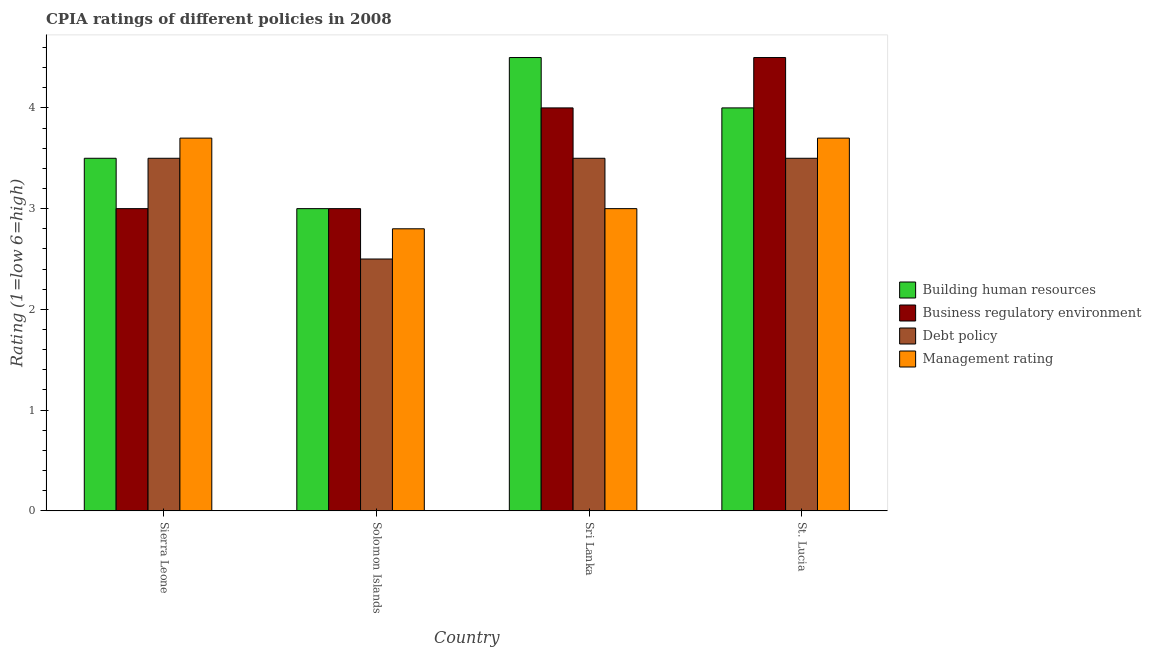How many different coloured bars are there?
Your answer should be very brief. 4. Are the number of bars per tick equal to the number of legend labels?
Ensure brevity in your answer.  Yes. How many bars are there on the 2nd tick from the left?
Provide a short and direct response. 4. What is the label of the 1st group of bars from the left?
Provide a succinct answer. Sierra Leone. In how many cases, is the number of bars for a given country not equal to the number of legend labels?
Provide a short and direct response. 0. What is the cpia rating of business regulatory environment in Sierra Leone?
Provide a short and direct response. 3. Across all countries, what is the minimum cpia rating of debt policy?
Offer a terse response. 2.5. In which country was the cpia rating of building human resources maximum?
Your response must be concise. Sri Lanka. In which country was the cpia rating of building human resources minimum?
Ensure brevity in your answer.  Solomon Islands. What is the difference between the cpia rating of building human resources in Solomon Islands and the cpia rating of management in St. Lucia?
Provide a succinct answer. -0.7. What is the average cpia rating of business regulatory environment per country?
Your response must be concise. 3.62. What is the difference between the cpia rating of building human resources and cpia rating of debt policy in St. Lucia?
Offer a very short reply. 0.5. In how many countries, is the cpia rating of building human resources greater than 2.8 ?
Your response must be concise. 4. Is the cpia rating of business regulatory environment in Solomon Islands less than that in St. Lucia?
Ensure brevity in your answer.  Yes. Is the difference between the cpia rating of business regulatory environment in Sri Lanka and St. Lucia greater than the difference between the cpia rating of building human resources in Sri Lanka and St. Lucia?
Your response must be concise. No. What is the difference between the highest and the lowest cpia rating of building human resources?
Offer a very short reply. 1.5. In how many countries, is the cpia rating of debt policy greater than the average cpia rating of debt policy taken over all countries?
Keep it short and to the point. 3. Is the sum of the cpia rating of business regulatory environment in Sierra Leone and St. Lucia greater than the maximum cpia rating of building human resources across all countries?
Make the answer very short. Yes. Is it the case that in every country, the sum of the cpia rating of management and cpia rating of debt policy is greater than the sum of cpia rating of building human resources and cpia rating of business regulatory environment?
Your response must be concise. No. What does the 4th bar from the left in St. Lucia represents?
Your answer should be very brief. Management rating. What does the 2nd bar from the right in Sri Lanka represents?
Offer a terse response. Debt policy. How many bars are there?
Provide a short and direct response. 16. Are all the bars in the graph horizontal?
Ensure brevity in your answer.  No. How many countries are there in the graph?
Your answer should be compact. 4. What is the difference between two consecutive major ticks on the Y-axis?
Make the answer very short. 1. Does the graph contain grids?
Provide a short and direct response. No. Where does the legend appear in the graph?
Your answer should be very brief. Center right. How are the legend labels stacked?
Offer a terse response. Vertical. What is the title of the graph?
Provide a short and direct response. CPIA ratings of different policies in 2008. What is the label or title of the Y-axis?
Provide a short and direct response. Rating (1=low 6=high). What is the Rating (1=low 6=high) of Business regulatory environment in Sierra Leone?
Keep it short and to the point. 3. What is the Rating (1=low 6=high) in Debt policy in Sierra Leone?
Provide a succinct answer. 3.5. What is the Rating (1=low 6=high) of Business regulatory environment in Solomon Islands?
Your answer should be compact. 3. What is the Rating (1=low 6=high) of Building human resources in Sri Lanka?
Your answer should be very brief. 4.5. What is the Rating (1=low 6=high) in Business regulatory environment in Sri Lanka?
Your response must be concise. 4. Across all countries, what is the maximum Rating (1=low 6=high) of Business regulatory environment?
Provide a succinct answer. 4.5. Across all countries, what is the maximum Rating (1=low 6=high) in Management rating?
Your response must be concise. 3.7. Across all countries, what is the minimum Rating (1=low 6=high) of Building human resources?
Your answer should be very brief. 3. Across all countries, what is the minimum Rating (1=low 6=high) of Business regulatory environment?
Ensure brevity in your answer.  3. Across all countries, what is the minimum Rating (1=low 6=high) of Debt policy?
Give a very brief answer. 2.5. What is the total Rating (1=low 6=high) in Business regulatory environment in the graph?
Give a very brief answer. 14.5. What is the total Rating (1=low 6=high) in Debt policy in the graph?
Provide a short and direct response. 13. What is the difference between the Rating (1=low 6=high) in Management rating in Sierra Leone and that in Solomon Islands?
Ensure brevity in your answer.  0.9. What is the difference between the Rating (1=low 6=high) in Debt policy in Sierra Leone and that in Sri Lanka?
Your response must be concise. 0. What is the difference between the Rating (1=low 6=high) of Business regulatory environment in Sierra Leone and that in St. Lucia?
Ensure brevity in your answer.  -1.5. What is the difference between the Rating (1=low 6=high) in Building human resources in Solomon Islands and that in Sri Lanka?
Your response must be concise. -1.5. What is the difference between the Rating (1=low 6=high) in Debt policy in Solomon Islands and that in Sri Lanka?
Give a very brief answer. -1. What is the difference between the Rating (1=low 6=high) of Debt policy in Solomon Islands and that in St. Lucia?
Keep it short and to the point. -1. What is the difference between the Rating (1=low 6=high) in Building human resources in Sri Lanka and that in St. Lucia?
Give a very brief answer. 0.5. What is the difference between the Rating (1=low 6=high) of Business regulatory environment in Sri Lanka and that in St. Lucia?
Your answer should be very brief. -0.5. What is the difference between the Rating (1=low 6=high) in Debt policy in Sri Lanka and that in St. Lucia?
Provide a short and direct response. 0. What is the difference between the Rating (1=low 6=high) of Building human resources in Sierra Leone and the Rating (1=low 6=high) of Debt policy in Solomon Islands?
Give a very brief answer. 1. What is the difference between the Rating (1=low 6=high) in Business regulatory environment in Sierra Leone and the Rating (1=low 6=high) in Debt policy in Solomon Islands?
Ensure brevity in your answer.  0.5. What is the difference between the Rating (1=low 6=high) in Business regulatory environment in Sierra Leone and the Rating (1=low 6=high) in Management rating in Solomon Islands?
Ensure brevity in your answer.  0.2. What is the difference between the Rating (1=low 6=high) in Debt policy in Sierra Leone and the Rating (1=low 6=high) in Management rating in Solomon Islands?
Offer a very short reply. 0.7. What is the difference between the Rating (1=low 6=high) of Business regulatory environment in Sierra Leone and the Rating (1=low 6=high) of Debt policy in Sri Lanka?
Ensure brevity in your answer.  -0.5. What is the difference between the Rating (1=low 6=high) in Building human resources in Sierra Leone and the Rating (1=low 6=high) in Business regulatory environment in St. Lucia?
Provide a short and direct response. -1. What is the difference between the Rating (1=low 6=high) of Building human resources in Sierra Leone and the Rating (1=low 6=high) of Debt policy in St. Lucia?
Keep it short and to the point. 0. What is the difference between the Rating (1=low 6=high) in Building human resources in Sierra Leone and the Rating (1=low 6=high) in Management rating in St. Lucia?
Provide a short and direct response. -0.2. What is the difference between the Rating (1=low 6=high) of Business regulatory environment in Sierra Leone and the Rating (1=low 6=high) of Management rating in St. Lucia?
Your response must be concise. -0.7. What is the difference between the Rating (1=low 6=high) in Building human resources in Solomon Islands and the Rating (1=low 6=high) in Business regulatory environment in Sri Lanka?
Your response must be concise. -1. What is the difference between the Rating (1=low 6=high) of Business regulatory environment in Solomon Islands and the Rating (1=low 6=high) of Management rating in Sri Lanka?
Your answer should be compact. 0. What is the difference between the Rating (1=low 6=high) of Debt policy in Solomon Islands and the Rating (1=low 6=high) of Management rating in Sri Lanka?
Your answer should be very brief. -0.5. What is the difference between the Rating (1=low 6=high) of Business regulatory environment in Solomon Islands and the Rating (1=low 6=high) of Management rating in St. Lucia?
Offer a very short reply. -0.7. What is the difference between the Rating (1=low 6=high) in Debt policy in Solomon Islands and the Rating (1=low 6=high) in Management rating in St. Lucia?
Your answer should be very brief. -1.2. What is the difference between the Rating (1=low 6=high) of Building human resources in Sri Lanka and the Rating (1=low 6=high) of Business regulatory environment in St. Lucia?
Offer a very short reply. 0. What is the difference between the Rating (1=low 6=high) in Building human resources in Sri Lanka and the Rating (1=low 6=high) in Management rating in St. Lucia?
Provide a short and direct response. 0.8. What is the difference between the Rating (1=low 6=high) of Business regulatory environment in Sri Lanka and the Rating (1=low 6=high) of Debt policy in St. Lucia?
Provide a succinct answer. 0.5. What is the difference between the Rating (1=low 6=high) in Debt policy in Sri Lanka and the Rating (1=low 6=high) in Management rating in St. Lucia?
Ensure brevity in your answer.  -0.2. What is the average Rating (1=low 6=high) in Building human resources per country?
Provide a short and direct response. 3.75. What is the average Rating (1=low 6=high) in Business regulatory environment per country?
Your answer should be very brief. 3.62. What is the average Rating (1=low 6=high) in Debt policy per country?
Your response must be concise. 3.25. What is the difference between the Rating (1=low 6=high) of Building human resources and Rating (1=low 6=high) of Business regulatory environment in Sierra Leone?
Offer a very short reply. 0.5. What is the difference between the Rating (1=low 6=high) in Building human resources and Rating (1=low 6=high) in Business regulatory environment in Solomon Islands?
Provide a succinct answer. 0. What is the difference between the Rating (1=low 6=high) of Building human resources and Rating (1=low 6=high) of Debt policy in Solomon Islands?
Offer a terse response. 0.5. What is the difference between the Rating (1=low 6=high) in Business regulatory environment and Rating (1=low 6=high) in Debt policy in Solomon Islands?
Your answer should be very brief. 0.5. What is the difference between the Rating (1=low 6=high) in Building human resources and Rating (1=low 6=high) in Business regulatory environment in Sri Lanka?
Your answer should be compact. 0.5. What is the difference between the Rating (1=low 6=high) of Building human resources and Rating (1=low 6=high) of Management rating in Sri Lanka?
Your answer should be very brief. 1.5. What is the difference between the Rating (1=low 6=high) in Business regulatory environment and Rating (1=low 6=high) in Debt policy in Sri Lanka?
Make the answer very short. 0.5. What is the difference between the Rating (1=low 6=high) in Business regulatory environment and Rating (1=low 6=high) in Management rating in Sri Lanka?
Your answer should be very brief. 1. What is the difference between the Rating (1=low 6=high) in Building human resources and Rating (1=low 6=high) in Business regulatory environment in St. Lucia?
Your answer should be very brief. -0.5. What is the difference between the Rating (1=low 6=high) of Building human resources and Rating (1=low 6=high) of Debt policy in St. Lucia?
Make the answer very short. 0.5. What is the difference between the Rating (1=low 6=high) in Building human resources and Rating (1=low 6=high) in Management rating in St. Lucia?
Ensure brevity in your answer.  0.3. What is the difference between the Rating (1=low 6=high) of Business regulatory environment and Rating (1=low 6=high) of Debt policy in St. Lucia?
Provide a short and direct response. 1. What is the difference between the Rating (1=low 6=high) in Business regulatory environment and Rating (1=low 6=high) in Management rating in St. Lucia?
Provide a short and direct response. 0.8. What is the difference between the Rating (1=low 6=high) of Debt policy and Rating (1=low 6=high) of Management rating in St. Lucia?
Your answer should be very brief. -0.2. What is the ratio of the Rating (1=low 6=high) in Debt policy in Sierra Leone to that in Solomon Islands?
Give a very brief answer. 1.4. What is the ratio of the Rating (1=low 6=high) in Management rating in Sierra Leone to that in Solomon Islands?
Give a very brief answer. 1.32. What is the ratio of the Rating (1=low 6=high) of Building human resources in Sierra Leone to that in Sri Lanka?
Your answer should be very brief. 0.78. What is the ratio of the Rating (1=low 6=high) of Business regulatory environment in Sierra Leone to that in Sri Lanka?
Provide a short and direct response. 0.75. What is the ratio of the Rating (1=low 6=high) in Debt policy in Sierra Leone to that in Sri Lanka?
Offer a terse response. 1. What is the ratio of the Rating (1=low 6=high) of Management rating in Sierra Leone to that in Sri Lanka?
Provide a short and direct response. 1.23. What is the ratio of the Rating (1=low 6=high) of Building human resources in Sierra Leone to that in St. Lucia?
Provide a succinct answer. 0.88. What is the ratio of the Rating (1=low 6=high) of Business regulatory environment in Sierra Leone to that in St. Lucia?
Your response must be concise. 0.67. What is the ratio of the Rating (1=low 6=high) of Management rating in Sierra Leone to that in St. Lucia?
Give a very brief answer. 1. What is the ratio of the Rating (1=low 6=high) in Business regulatory environment in Solomon Islands to that in St. Lucia?
Ensure brevity in your answer.  0.67. What is the ratio of the Rating (1=low 6=high) of Management rating in Solomon Islands to that in St. Lucia?
Offer a terse response. 0.76. What is the ratio of the Rating (1=low 6=high) of Building human resources in Sri Lanka to that in St. Lucia?
Offer a very short reply. 1.12. What is the ratio of the Rating (1=low 6=high) in Business regulatory environment in Sri Lanka to that in St. Lucia?
Your answer should be compact. 0.89. What is the ratio of the Rating (1=low 6=high) in Debt policy in Sri Lanka to that in St. Lucia?
Keep it short and to the point. 1. What is the ratio of the Rating (1=low 6=high) in Management rating in Sri Lanka to that in St. Lucia?
Your response must be concise. 0.81. What is the difference between the highest and the second highest Rating (1=low 6=high) in Business regulatory environment?
Your answer should be very brief. 0.5. What is the difference between the highest and the lowest Rating (1=low 6=high) of Building human resources?
Offer a very short reply. 1.5. What is the difference between the highest and the lowest Rating (1=low 6=high) in Debt policy?
Your answer should be compact. 1. What is the difference between the highest and the lowest Rating (1=low 6=high) in Management rating?
Offer a very short reply. 0.9. 